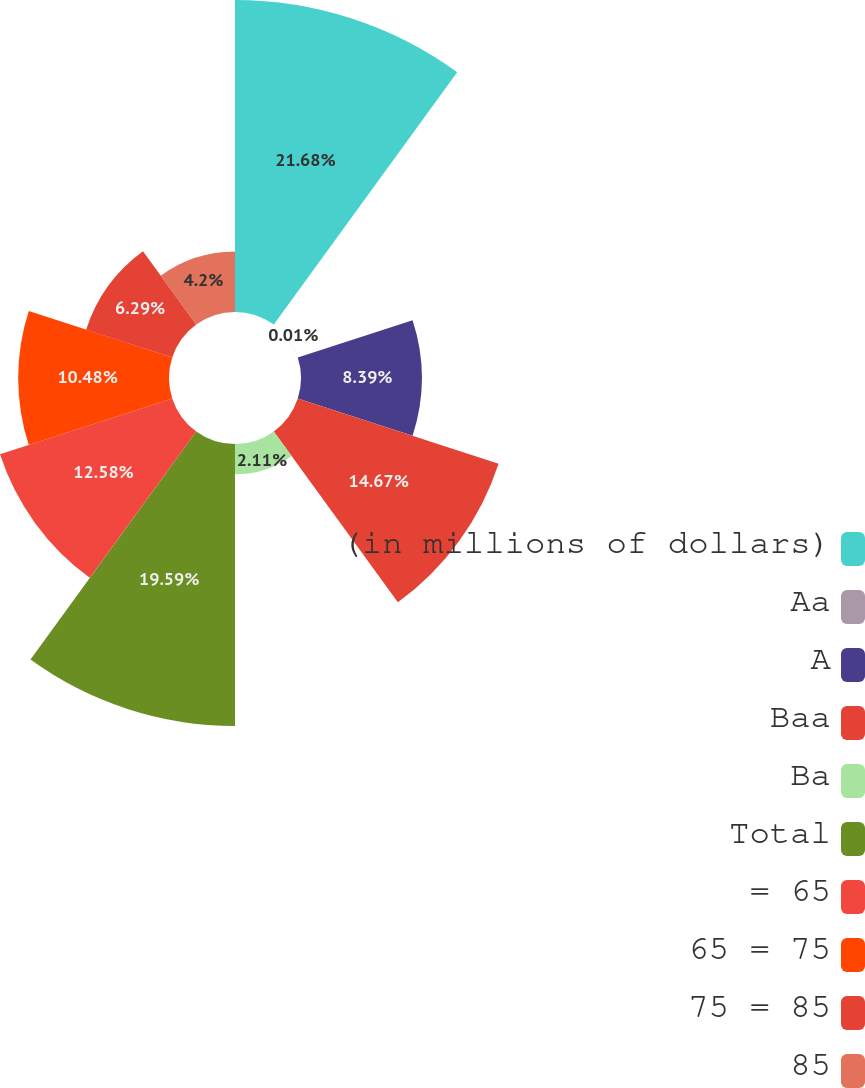<chart> <loc_0><loc_0><loc_500><loc_500><pie_chart><fcel>(in millions of dollars)<fcel>Aa<fcel>A<fcel>Baa<fcel>Ba<fcel>Total<fcel>= 65<fcel>65 = 75<fcel>75 = 85<fcel>85<nl><fcel>21.68%<fcel>0.01%<fcel>8.39%<fcel>14.67%<fcel>2.11%<fcel>19.59%<fcel>12.58%<fcel>10.48%<fcel>6.29%<fcel>4.2%<nl></chart> 